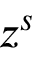Convert formula to latex. <formula><loc_0><loc_0><loc_500><loc_500>z ^ { s }</formula> 